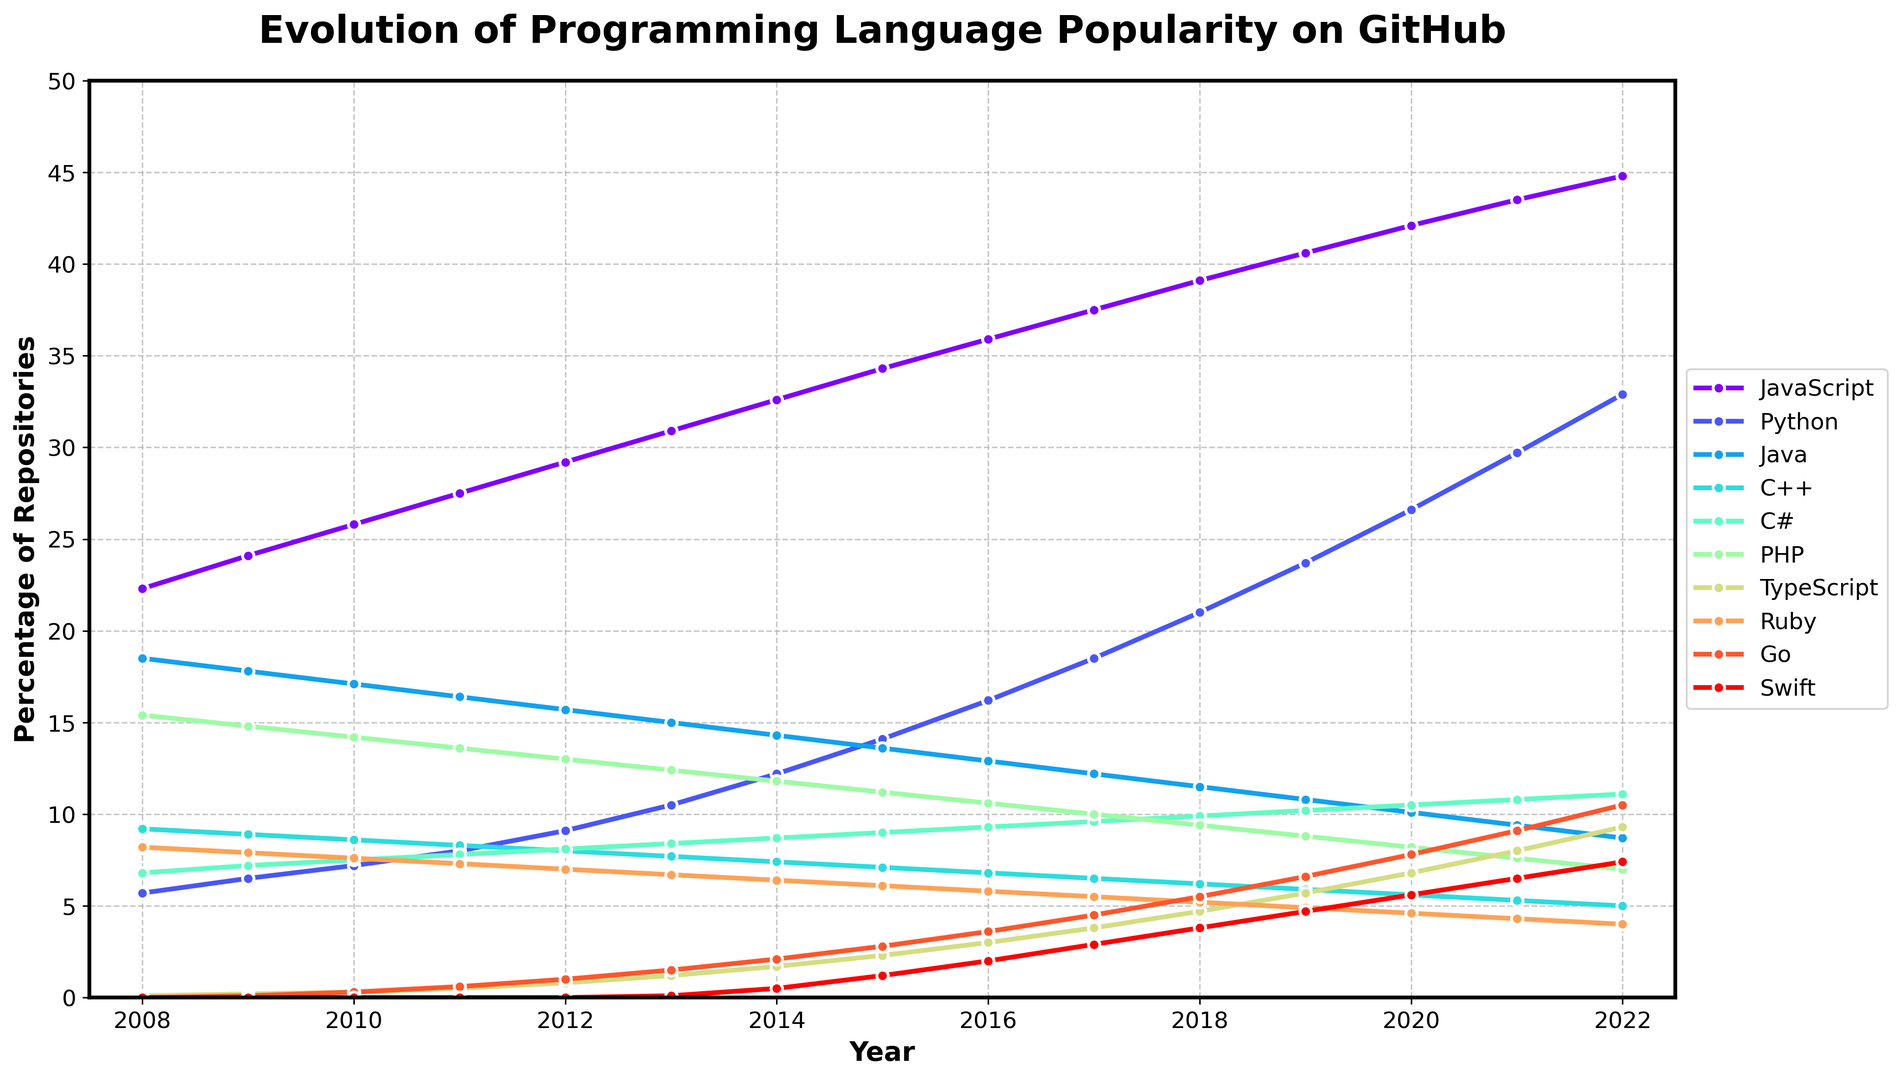What year did Python's popularity first surpass 20%? Find the point on the graph where Python's line crosses the 20% mark and check the corresponding year. This occurs between 2017 and 2018.
Answer: 2018 What was the trend for Java between 2008 and 2022? Observe the line representing Java on the chart. It shows a consistent decline from 18.5% in 2008 to 8.7% in 2022. The overall trend is a steady decrease in popularity.
Answer: Decreasing What is the difference in popularity between JavaScript and Python in 2022? Locate the points for JavaScript and Python on the graph for the year 2022. JavaScript is at 44.8% and Python is at 32.9%. Subtract Python’s percentage from JavaScript’s.
Answer: 11.9 Which programming language showed the most significant growth in popularity from 2008 to 2022? Examine the slopes of the lines representing each programming language. Python’s line increases significantly from 5.7% in 2008 to 32.9% in 2022. This is the most substantial growth among all the languages.
Answer: Python List the languages that surpassed the 10% popularity mark in 2022. Look at the points for the year 2022 and check which ones are above 10%. The languages are JavaScript, Python, and C#.
Answer: JavaScript, Python, C# Between 2009 and 2010, which language exhibited a comparable increase in popularity to Python's? First, find Python’s increase between 2009 and 2010 (7.2 - 6.5 = 0.7). Next, compare this with other languages. Ruby increased from 7.9 to 7.6, a decrease. TypeScript and Go do not have significant data until later years. C# increased from 7.2 to 7.5, an increase of 0.3. JavaScript increased from 24.1 to 25.8, an increase of 1.7, which is much larger. None of the others match closely.
Answer: None What was PHP’s popularity trend from 2008 to 2022? PHP's points on the graph trend downward. It starts at 15.4% in 2008 and falls to 7.0% in 2022. This indicates a consistent decline.
Answer: Decreasing What is the average popularity of TypeScript from 2015 to 2022? Locate TypeScript’s percentages for each year: 2015 (2.3), 2016 (3.0), 2017 (3.8), 2018 (4.7), 2019 (5.7), 2020 (6.8), 2021 (8.0), and 2022 (9.3). Sum these (2.3 + 3.0 + 3.8 + 4.7 + 5.7 + 6.8 + 8.0 + 9.3 = 43.6) and divide by the number of years (8).
Answer: 5.45 